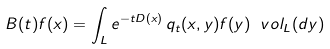<formula> <loc_0><loc_0><loc_500><loc_500>B ( t ) f ( x ) = \int _ { L } e ^ { - t D ( x ) } \, q _ { t } ( x , y ) f ( y ) \ v o l _ { L } ( d y )</formula> 